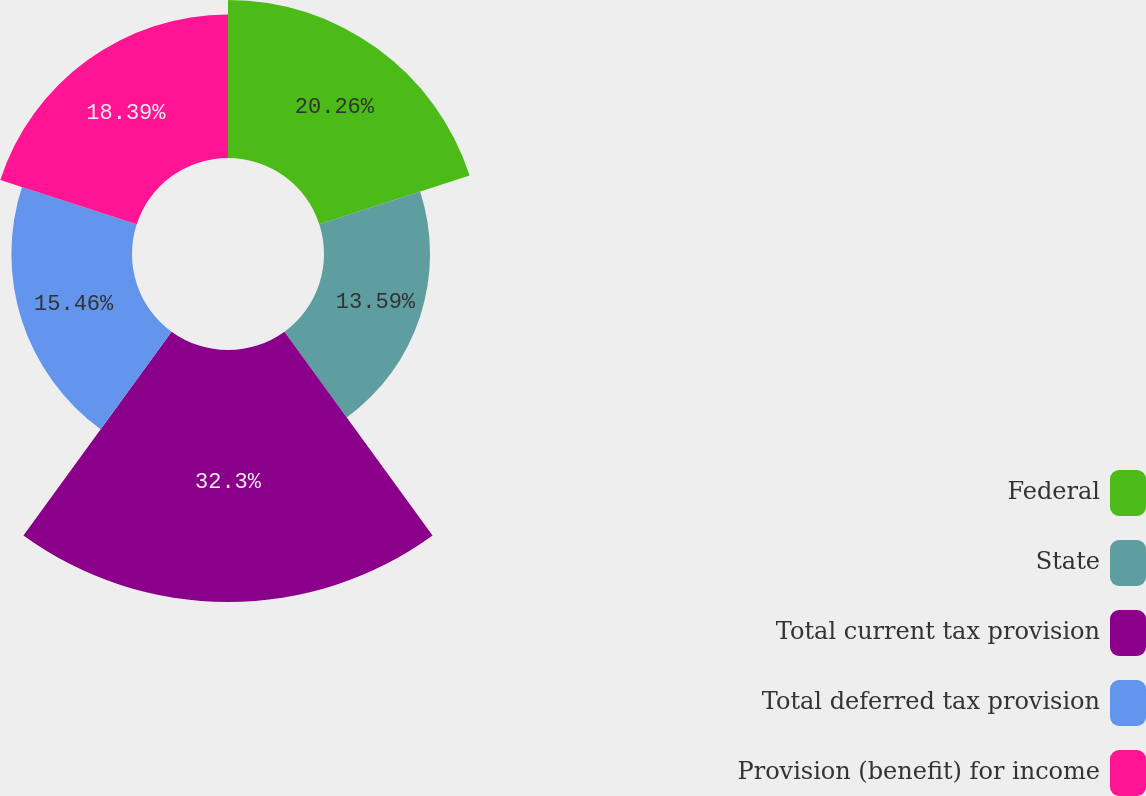Convert chart to OTSL. <chart><loc_0><loc_0><loc_500><loc_500><pie_chart><fcel>Federal<fcel>State<fcel>Total current tax provision<fcel>Total deferred tax provision<fcel>Provision (benefit) for income<nl><fcel>20.26%<fcel>13.59%<fcel>32.3%<fcel>15.46%<fcel>18.39%<nl></chart> 